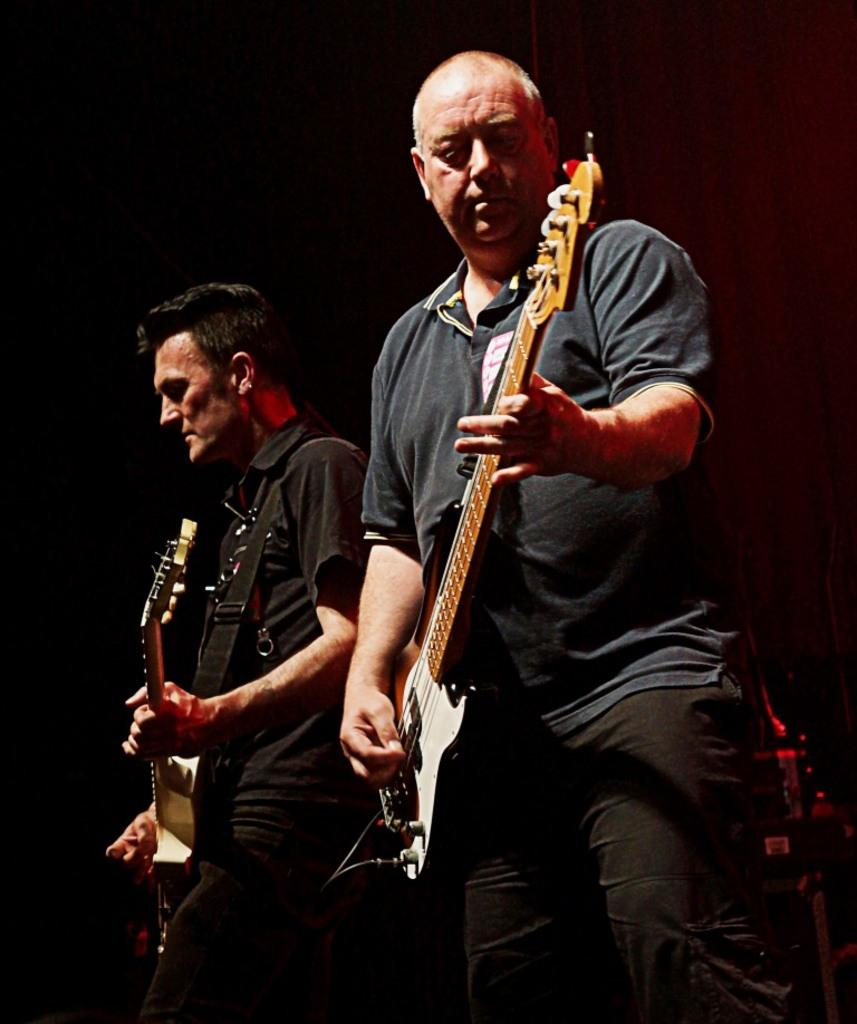Who is present in the image? There are people in the image. What are the people doing in the image? The people are playing guitar. Where is the guitar playing taking place in the image? The guitar playing is happening in the center of the image. What type of cushion is being used to support the cannon in the image? There is no cushion or cannon present in the image; it features people playing guitar. 